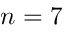<formula> <loc_0><loc_0><loc_500><loc_500>n = 7</formula> 